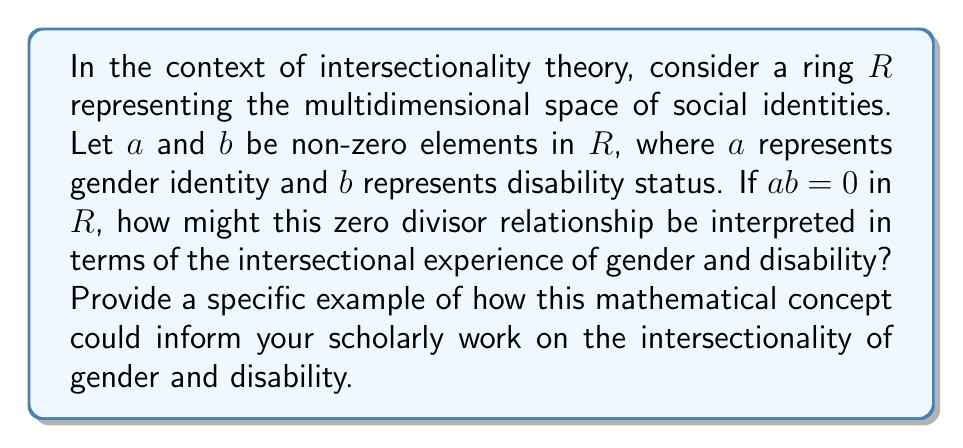Teach me how to tackle this problem. To understand this question, we need to break it down into its mathematical and sociological components:

1. Ring Theory Concept:
   In ring theory, a zero divisor is a non-zero element $a$ in a ring $R$ such that there exists another non-zero element $b$ where $ab = 0$. This concept is crucial because it indicates a loss of information when these elements are multiplied.

2. Intersectionality Interpretation:
   In the context of intersectionality, we can interpret the ring $R$ as the space of social identities. Each element in $R$ represents a specific aspect of identity (e.g., gender, race, disability status, etc.).

3. Zero Divisors in Intersectionality:
   If $a$ (gender identity) and $b$ (disability status) are zero divisors, meaning $ab = 0$, this could be interpreted as follows:
   - The interaction between gender identity and disability status results in a unique experience that cannot be fully understood by considering these identities separately.
   - The product being zero suggests that some aspects of these identities may be "cancelled out" or rendered invisible when they intersect.

4. Scholarly Application:
   This mathematical concept could inform scholarly work on intersectionality by:
   - Providing a formal framework to discuss how different aspects of identity interact.
   - Highlighting the importance of considering multiple identities simultaneously, as their interaction (multiplication) yields results that cannot be predicted by examining each identity in isolation.
   - Suggesting that certain combinations of identities may lead to experiences or challenges that are overlooked when focusing on single-axis frameworks of discrimination.

5. Example:
   A specific example could be studying how the experience of a disabled woman differs from what might be expected by considering gender discrimination and ableism separately. The zero divisor concept suggests that this intersectional experience may have unique characteristics that are not simply the sum of gender-based and disability-based discriminations.

This mathematical analogy provides a rigorous way to conceptualize and discuss the complex interactions between different aspects of identity in intersectionality theory.
Answer: The zero divisor relationship $ab = 0$ in the ring $R$ of social identities can be interpreted as the unique, often overlooked experiences that emerge at the intersection of gender identity ($a$) and disability status ($b$). This mathematical concept informs intersectionality scholarship by emphasizing that the interaction of these identities produces experiences that cannot be fully understood by examining gender and disability separately, highlighting the need for nuanced, multi-dimensional analysis in studying marginalized identities. 